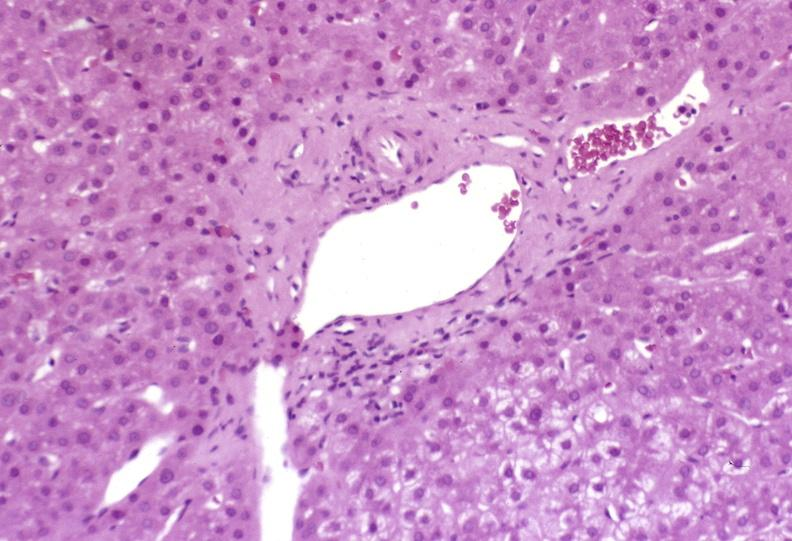what is present?
Answer the question using a single word or phrase. Hepatobiliary 